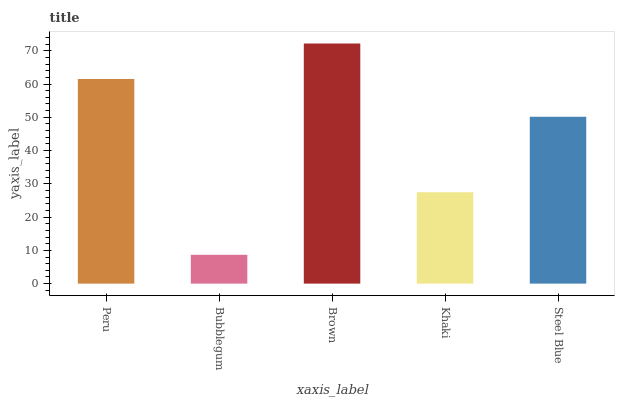Is Bubblegum the minimum?
Answer yes or no. Yes. Is Brown the maximum?
Answer yes or no. Yes. Is Brown the minimum?
Answer yes or no. No. Is Bubblegum the maximum?
Answer yes or no. No. Is Brown greater than Bubblegum?
Answer yes or no. Yes. Is Bubblegum less than Brown?
Answer yes or no. Yes. Is Bubblegum greater than Brown?
Answer yes or no. No. Is Brown less than Bubblegum?
Answer yes or no. No. Is Steel Blue the high median?
Answer yes or no. Yes. Is Steel Blue the low median?
Answer yes or no. Yes. Is Peru the high median?
Answer yes or no. No. Is Brown the low median?
Answer yes or no. No. 